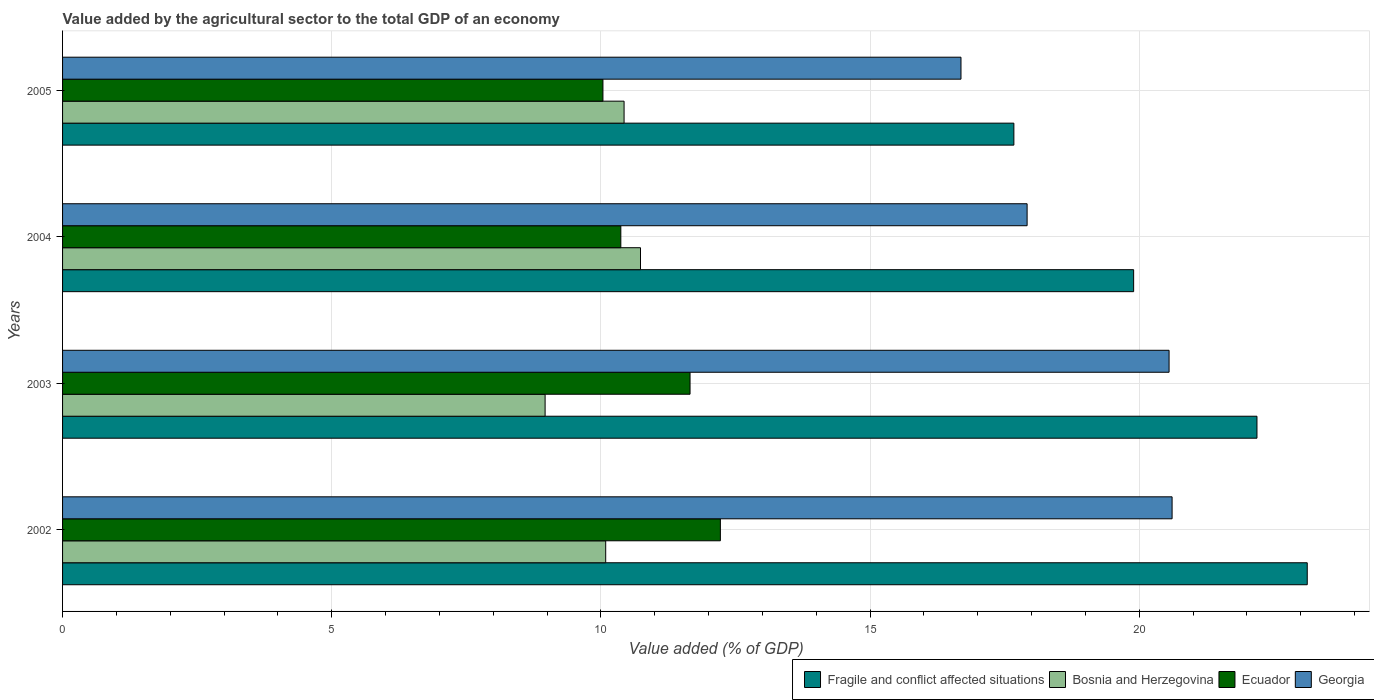Are the number of bars per tick equal to the number of legend labels?
Offer a terse response. Yes. Are the number of bars on each tick of the Y-axis equal?
Your response must be concise. Yes. How many bars are there on the 1st tick from the top?
Provide a succinct answer. 4. What is the value added by the agricultural sector to the total GDP in Bosnia and Herzegovina in 2003?
Make the answer very short. 8.96. Across all years, what is the maximum value added by the agricultural sector to the total GDP in Ecuador?
Give a very brief answer. 12.22. Across all years, what is the minimum value added by the agricultural sector to the total GDP in Fragile and conflict affected situations?
Keep it short and to the point. 17.67. In which year was the value added by the agricultural sector to the total GDP in Fragile and conflict affected situations minimum?
Ensure brevity in your answer.  2005. What is the total value added by the agricultural sector to the total GDP in Fragile and conflict affected situations in the graph?
Give a very brief answer. 82.88. What is the difference between the value added by the agricultural sector to the total GDP in Bosnia and Herzegovina in 2004 and that in 2005?
Your answer should be very brief. 0.31. What is the difference between the value added by the agricultural sector to the total GDP in Bosnia and Herzegovina in 2005 and the value added by the agricultural sector to the total GDP in Fragile and conflict affected situations in 2003?
Give a very brief answer. -11.76. What is the average value added by the agricultural sector to the total GDP in Ecuador per year?
Make the answer very short. 11.07. In the year 2005, what is the difference between the value added by the agricultural sector to the total GDP in Fragile and conflict affected situations and value added by the agricultural sector to the total GDP in Ecuador?
Your response must be concise. 7.63. In how many years, is the value added by the agricultural sector to the total GDP in Fragile and conflict affected situations greater than 5 %?
Provide a succinct answer. 4. What is the ratio of the value added by the agricultural sector to the total GDP in Fragile and conflict affected situations in 2002 to that in 2003?
Offer a terse response. 1.04. Is the difference between the value added by the agricultural sector to the total GDP in Fragile and conflict affected situations in 2002 and 2003 greater than the difference between the value added by the agricultural sector to the total GDP in Ecuador in 2002 and 2003?
Your answer should be compact. Yes. What is the difference between the highest and the second highest value added by the agricultural sector to the total GDP in Bosnia and Herzegovina?
Offer a very short reply. 0.31. What is the difference between the highest and the lowest value added by the agricultural sector to the total GDP in Georgia?
Your response must be concise. 3.92. In how many years, is the value added by the agricultural sector to the total GDP in Fragile and conflict affected situations greater than the average value added by the agricultural sector to the total GDP in Fragile and conflict affected situations taken over all years?
Provide a succinct answer. 2. What does the 1st bar from the top in 2002 represents?
Provide a short and direct response. Georgia. What does the 2nd bar from the bottom in 2002 represents?
Provide a short and direct response. Bosnia and Herzegovina. Is it the case that in every year, the sum of the value added by the agricultural sector to the total GDP in Bosnia and Herzegovina and value added by the agricultural sector to the total GDP in Fragile and conflict affected situations is greater than the value added by the agricultural sector to the total GDP in Ecuador?
Provide a succinct answer. Yes. How many years are there in the graph?
Your answer should be compact. 4. Are the values on the major ticks of X-axis written in scientific E-notation?
Provide a short and direct response. No. Does the graph contain any zero values?
Keep it short and to the point. No. What is the title of the graph?
Keep it short and to the point. Value added by the agricultural sector to the total GDP of an economy. What is the label or title of the X-axis?
Your response must be concise. Value added (% of GDP). What is the Value added (% of GDP) in Fragile and conflict affected situations in 2002?
Ensure brevity in your answer.  23.12. What is the Value added (% of GDP) in Bosnia and Herzegovina in 2002?
Make the answer very short. 10.09. What is the Value added (% of GDP) in Ecuador in 2002?
Offer a terse response. 12.22. What is the Value added (% of GDP) of Georgia in 2002?
Provide a short and direct response. 20.61. What is the Value added (% of GDP) of Fragile and conflict affected situations in 2003?
Your answer should be compact. 22.19. What is the Value added (% of GDP) in Bosnia and Herzegovina in 2003?
Make the answer very short. 8.96. What is the Value added (% of GDP) of Ecuador in 2003?
Offer a very short reply. 11.66. What is the Value added (% of GDP) in Georgia in 2003?
Offer a very short reply. 20.55. What is the Value added (% of GDP) of Fragile and conflict affected situations in 2004?
Your answer should be compact. 19.9. What is the Value added (% of GDP) of Bosnia and Herzegovina in 2004?
Keep it short and to the point. 10.74. What is the Value added (% of GDP) in Ecuador in 2004?
Offer a very short reply. 10.37. What is the Value added (% of GDP) of Georgia in 2004?
Give a very brief answer. 17.92. What is the Value added (% of GDP) of Fragile and conflict affected situations in 2005?
Your answer should be very brief. 17.67. What is the Value added (% of GDP) in Bosnia and Herzegovina in 2005?
Make the answer very short. 10.43. What is the Value added (% of GDP) of Ecuador in 2005?
Make the answer very short. 10.04. What is the Value added (% of GDP) of Georgia in 2005?
Offer a terse response. 16.69. Across all years, what is the maximum Value added (% of GDP) in Fragile and conflict affected situations?
Keep it short and to the point. 23.12. Across all years, what is the maximum Value added (% of GDP) in Bosnia and Herzegovina?
Ensure brevity in your answer.  10.74. Across all years, what is the maximum Value added (% of GDP) in Ecuador?
Ensure brevity in your answer.  12.22. Across all years, what is the maximum Value added (% of GDP) of Georgia?
Your answer should be very brief. 20.61. Across all years, what is the minimum Value added (% of GDP) in Fragile and conflict affected situations?
Your answer should be compact. 17.67. Across all years, what is the minimum Value added (% of GDP) in Bosnia and Herzegovina?
Give a very brief answer. 8.96. Across all years, what is the minimum Value added (% of GDP) in Ecuador?
Your answer should be compact. 10.04. Across all years, what is the minimum Value added (% of GDP) of Georgia?
Your response must be concise. 16.69. What is the total Value added (% of GDP) in Fragile and conflict affected situations in the graph?
Your response must be concise. 82.88. What is the total Value added (% of GDP) of Bosnia and Herzegovina in the graph?
Your answer should be very brief. 40.22. What is the total Value added (% of GDP) of Ecuador in the graph?
Your answer should be very brief. 44.28. What is the total Value added (% of GDP) in Georgia in the graph?
Your answer should be very brief. 75.77. What is the difference between the Value added (% of GDP) of Fragile and conflict affected situations in 2002 and that in 2003?
Offer a very short reply. 0.93. What is the difference between the Value added (% of GDP) of Bosnia and Herzegovina in 2002 and that in 2003?
Offer a terse response. 1.13. What is the difference between the Value added (% of GDP) in Ecuador in 2002 and that in 2003?
Your answer should be very brief. 0.56. What is the difference between the Value added (% of GDP) in Georgia in 2002 and that in 2003?
Ensure brevity in your answer.  0.06. What is the difference between the Value added (% of GDP) in Fragile and conflict affected situations in 2002 and that in 2004?
Your response must be concise. 3.23. What is the difference between the Value added (% of GDP) of Bosnia and Herzegovina in 2002 and that in 2004?
Make the answer very short. -0.65. What is the difference between the Value added (% of GDP) in Ecuador in 2002 and that in 2004?
Keep it short and to the point. 1.85. What is the difference between the Value added (% of GDP) of Georgia in 2002 and that in 2004?
Your answer should be compact. 2.69. What is the difference between the Value added (% of GDP) of Fragile and conflict affected situations in 2002 and that in 2005?
Give a very brief answer. 5.45. What is the difference between the Value added (% of GDP) in Bosnia and Herzegovina in 2002 and that in 2005?
Offer a very short reply. -0.34. What is the difference between the Value added (% of GDP) of Ecuador in 2002 and that in 2005?
Provide a short and direct response. 2.18. What is the difference between the Value added (% of GDP) of Georgia in 2002 and that in 2005?
Give a very brief answer. 3.92. What is the difference between the Value added (% of GDP) in Fragile and conflict affected situations in 2003 and that in 2004?
Provide a short and direct response. 2.29. What is the difference between the Value added (% of GDP) of Bosnia and Herzegovina in 2003 and that in 2004?
Your answer should be very brief. -1.77. What is the difference between the Value added (% of GDP) in Ecuador in 2003 and that in 2004?
Give a very brief answer. 1.29. What is the difference between the Value added (% of GDP) of Georgia in 2003 and that in 2004?
Your answer should be compact. 2.64. What is the difference between the Value added (% of GDP) in Fragile and conflict affected situations in 2003 and that in 2005?
Provide a short and direct response. 4.52. What is the difference between the Value added (% of GDP) in Bosnia and Herzegovina in 2003 and that in 2005?
Your answer should be compact. -1.47. What is the difference between the Value added (% of GDP) of Ecuador in 2003 and that in 2005?
Your response must be concise. 1.62. What is the difference between the Value added (% of GDP) of Georgia in 2003 and that in 2005?
Give a very brief answer. 3.87. What is the difference between the Value added (% of GDP) of Fragile and conflict affected situations in 2004 and that in 2005?
Your response must be concise. 2.22. What is the difference between the Value added (% of GDP) in Bosnia and Herzegovina in 2004 and that in 2005?
Provide a short and direct response. 0.31. What is the difference between the Value added (% of GDP) in Ecuador in 2004 and that in 2005?
Your answer should be very brief. 0.33. What is the difference between the Value added (% of GDP) of Georgia in 2004 and that in 2005?
Your answer should be compact. 1.23. What is the difference between the Value added (% of GDP) in Fragile and conflict affected situations in 2002 and the Value added (% of GDP) in Bosnia and Herzegovina in 2003?
Provide a succinct answer. 14.16. What is the difference between the Value added (% of GDP) in Fragile and conflict affected situations in 2002 and the Value added (% of GDP) in Ecuador in 2003?
Ensure brevity in your answer.  11.47. What is the difference between the Value added (% of GDP) of Fragile and conflict affected situations in 2002 and the Value added (% of GDP) of Georgia in 2003?
Your answer should be very brief. 2.57. What is the difference between the Value added (% of GDP) in Bosnia and Herzegovina in 2002 and the Value added (% of GDP) in Ecuador in 2003?
Your answer should be compact. -1.57. What is the difference between the Value added (% of GDP) in Bosnia and Herzegovina in 2002 and the Value added (% of GDP) in Georgia in 2003?
Your answer should be very brief. -10.47. What is the difference between the Value added (% of GDP) of Ecuador in 2002 and the Value added (% of GDP) of Georgia in 2003?
Provide a succinct answer. -8.34. What is the difference between the Value added (% of GDP) of Fragile and conflict affected situations in 2002 and the Value added (% of GDP) of Bosnia and Herzegovina in 2004?
Ensure brevity in your answer.  12.39. What is the difference between the Value added (% of GDP) in Fragile and conflict affected situations in 2002 and the Value added (% of GDP) in Ecuador in 2004?
Keep it short and to the point. 12.75. What is the difference between the Value added (% of GDP) in Fragile and conflict affected situations in 2002 and the Value added (% of GDP) in Georgia in 2004?
Offer a very short reply. 5.2. What is the difference between the Value added (% of GDP) of Bosnia and Herzegovina in 2002 and the Value added (% of GDP) of Ecuador in 2004?
Provide a short and direct response. -0.28. What is the difference between the Value added (% of GDP) of Bosnia and Herzegovina in 2002 and the Value added (% of GDP) of Georgia in 2004?
Keep it short and to the point. -7.83. What is the difference between the Value added (% of GDP) of Ecuador in 2002 and the Value added (% of GDP) of Georgia in 2004?
Provide a short and direct response. -5.7. What is the difference between the Value added (% of GDP) in Fragile and conflict affected situations in 2002 and the Value added (% of GDP) in Bosnia and Herzegovina in 2005?
Your response must be concise. 12.69. What is the difference between the Value added (% of GDP) in Fragile and conflict affected situations in 2002 and the Value added (% of GDP) in Ecuador in 2005?
Your answer should be very brief. 13.08. What is the difference between the Value added (% of GDP) of Fragile and conflict affected situations in 2002 and the Value added (% of GDP) of Georgia in 2005?
Provide a short and direct response. 6.43. What is the difference between the Value added (% of GDP) in Bosnia and Herzegovina in 2002 and the Value added (% of GDP) in Ecuador in 2005?
Provide a succinct answer. 0.05. What is the difference between the Value added (% of GDP) in Bosnia and Herzegovina in 2002 and the Value added (% of GDP) in Georgia in 2005?
Your answer should be compact. -6.6. What is the difference between the Value added (% of GDP) in Ecuador in 2002 and the Value added (% of GDP) in Georgia in 2005?
Make the answer very short. -4.47. What is the difference between the Value added (% of GDP) of Fragile and conflict affected situations in 2003 and the Value added (% of GDP) of Bosnia and Herzegovina in 2004?
Offer a very short reply. 11.45. What is the difference between the Value added (% of GDP) in Fragile and conflict affected situations in 2003 and the Value added (% of GDP) in Ecuador in 2004?
Ensure brevity in your answer.  11.82. What is the difference between the Value added (% of GDP) in Fragile and conflict affected situations in 2003 and the Value added (% of GDP) in Georgia in 2004?
Your response must be concise. 4.27. What is the difference between the Value added (% of GDP) of Bosnia and Herzegovina in 2003 and the Value added (% of GDP) of Ecuador in 2004?
Provide a succinct answer. -1.41. What is the difference between the Value added (% of GDP) of Bosnia and Herzegovina in 2003 and the Value added (% of GDP) of Georgia in 2004?
Offer a terse response. -8.95. What is the difference between the Value added (% of GDP) in Ecuador in 2003 and the Value added (% of GDP) in Georgia in 2004?
Give a very brief answer. -6.26. What is the difference between the Value added (% of GDP) of Fragile and conflict affected situations in 2003 and the Value added (% of GDP) of Bosnia and Herzegovina in 2005?
Your answer should be very brief. 11.76. What is the difference between the Value added (% of GDP) of Fragile and conflict affected situations in 2003 and the Value added (% of GDP) of Ecuador in 2005?
Give a very brief answer. 12.15. What is the difference between the Value added (% of GDP) of Fragile and conflict affected situations in 2003 and the Value added (% of GDP) of Georgia in 2005?
Offer a very short reply. 5.5. What is the difference between the Value added (% of GDP) in Bosnia and Herzegovina in 2003 and the Value added (% of GDP) in Ecuador in 2005?
Make the answer very short. -1.07. What is the difference between the Value added (% of GDP) in Bosnia and Herzegovina in 2003 and the Value added (% of GDP) in Georgia in 2005?
Give a very brief answer. -7.73. What is the difference between the Value added (% of GDP) of Ecuador in 2003 and the Value added (% of GDP) of Georgia in 2005?
Your answer should be compact. -5.03. What is the difference between the Value added (% of GDP) of Fragile and conflict affected situations in 2004 and the Value added (% of GDP) of Bosnia and Herzegovina in 2005?
Ensure brevity in your answer.  9.47. What is the difference between the Value added (% of GDP) in Fragile and conflict affected situations in 2004 and the Value added (% of GDP) in Ecuador in 2005?
Ensure brevity in your answer.  9.86. What is the difference between the Value added (% of GDP) in Fragile and conflict affected situations in 2004 and the Value added (% of GDP) in Georgia in 2005?
Your answer should be very brief. 3.21. What is the difference between the Value added (% of GDP) in Bosnia and Herzegovina in 2004 and the Value added (% of GDP) in Ecuador in 2005?
Give a very brief answer. 0.7. What is the difference between the Value added (% of GDP) of Bosnia and Herzegovina in 2004 and the Value added (% of GDP) of Georgia in 2005?
Provide a succinct answer. -5.95. What is the difference between the Value added (% of GDP) of Ecuador in 2004 and the Value added (% of GDP) of Georgia in 2005?
Ensure brevity in your answer.  -6.32. What is the average Value added (% of GDP) in Fragile and conflict affected situations per year?
Provide a succinct answer. 20.72. What is the average Value added (% of GDP) in Bosnia and Herzegovina per year?
Ensure brevity in your answer.  10.05. What is the average Value added (% of GDP) in Ecuador per year?
Give a very brief answer. 11.07. What is the average Value added (% of GDP) in Georgia per year?
Ensure brevity in your answer.  18.94. In the year 2002, what is the difference between the Value added (% of GDP) in Fragile and conflict affected situations and Value added (% of GDP) in Bosnia and Herzegovina?
Give a very brief answer. 13.03. In the year 2002, what is the difference between the Value added (% of GDP) of Fragile and conflict affected situations and Value added (% of GDP) of Ecuador?
Your answer should be compact. 10.9. In the year 2002, what is the difference between the Value added (% of GDP) in Fragile and conflict affected situations and Value added (% of GDP) in Georgia?
Keep it short and to the point. 2.51. In the year 2002, what is the difference between the Value added (% of GDP) in Bosnia and Herzegovina and Value added (% of GDP) in Ecuador?
Provide a short and direct response. -2.13. In the year 2002, what is the difference between the Value added (% of GDP) in Bosnia and Herzegovina and Value added (% of GDP) in Georgia?
Ensure brevity in your answer.  -10.52. In the year 2002, what is the difference between the Value added (% of GDP) in Ecuador and Value added (% of GDP) in Georgia?
Your response must be concise. -8.39. In the year 2003, what is the difference between the Value added (% of GDP) in Fragile and conflict affected situations and Value added (% of GDP) in Bosnia and Herzegovina?
Provide a succinct answer. 13.22. In the year 2003, what is the difference between the Value added (% of GDP) in Fragile and conflict affected situations and Value added (% of GDP) in Ecuador?
Make the answer very short. 10.53. In the year 2003, what is the difference between the Value added (% of GDP) in Fragile and conflict affected situations and Value added (% of GDP) in Georgia?
Keep it short and to the point. 1.63. In the year 2003, what is the difference between the Value added (% of GDP) of Bosnia and Herzegovina and Value added (% of GDP) of Ecuador?
Ensure brevity in your answer.  -2.69. In the year 2003, what is the difference between the Value added (% of GDP) in Bosnia and Herzegovina and Value added (% of GDP) in Georgia?
Provide a short and direct response. -11.59. In the year 2003, what is the difference between the Value added (% of GDP) of Ecuador and Value added (% of GDP) of Georgia?
Give a very brief answer. -8.9. In the year 2004, what is the difference between the Value added (% of GDP) of Fragile and conflict affected situations and Value added (% of GDP) of Bosnia and Herzegovina?
Give a very brief answer. 9.16. In the year 2004, what is the difference between the Value added (% of GDP) of Fragile and conflict affected situations and Value added (% of GDP) of Ecuador?
Your answer should be compact. 9.53. In the year 2004, what is the difference between the Value added (% of GDP) of Fragile and conflict affected situations and Value added (% of GDP) of Georgia?
Offer a very short reply. 1.98. In the year 2004, what is the difference between the Value added (% of GDP) in Bosnia and Herzegovina and Value added (% of GDP) in Ecuador?
Ensure brevity in your answer.  0.37. In the year 2004, what is the difference between the Value added (% of GDP) of Bosnia and Herzegovina and Value added (% of GDP) of Georgia?
Your response must be concise. -7.18. In the year 2004, what is the difference between the Value added (% of GDP) in Ecuador and Value added (% of GDP) in Georgia?
Provide a short and direct response. -7.55. In the year 2005, what is the difference between the Value added (% of GDP) in Fragile and conflict affected situations and Value added (% of GDP) in Bosnia and Herzegovina?
Your response must be concise. 7.24. In the year 2005, what is the difference between the Value added (% of GDP) in Fragile and conflict affected situations and Value added (% of GDP) in Ecuador?
Ensure brevity in your answer.  7.63. In the year 2005, what is the difference between the Value added (% of GDP) in Fragile and conflict affected situations and Value added (% of GDP) in Georgia?
Offer a terse response. 0.98. In the year 2005, what is the difference between the Value added (% of GDP) of Bosnia and Herzegovina and Value added (% of GDP) of Ecuador?
Your response must be concise. 0.39. In the year 2005, what is the difference between the Value added (% of GDP) of Bosnia and Herzegovina and Value added (% of GDP) of Georgia?
Provide a short and direct response. -6.26. In the year 2005, what is the difference between the Value added (% of GDP) in Ecuador and Value added (% of GDP) in Georgia?
Your answer should be compact. -6.65. What is the ratio of the Value added (% of GDP) in Fragile and conflict affected situations in 2002 to that in 2003?
Offer a very short reply. 1.04. What is the ratio of the Value added (% of GDP) of Bosnia and Herzegovina in 2002 to that in 2003?
Ensure brevity in your answer.  1.13. What is the ratio of the Value added (% of GDP) in Ecuador in 2002 to that in 2003?
Your answer should be very brief. 1.05. What is the ratio of the Value added (% of GDP) in Fragile and conflict affected situations in 2002 to that in 2004?
Your response must be concise. 1.16. What is the ratio of the Value added (% of GDP) of Bosnia and Herzegovina in 2002 to that in 2004?
Offer a very short reply. 0.94. What is the ratio of the Value added (% of GDP) of Ecuador in 2002 to that in 2004?
Offer a terse response. 1.18. What is the ratio of the Value added (% of GDP) in Georgia in 2002 to that in 2004?
Provide a succinct answer. 1.15. What is the ratio of the Value added (% of GDP) of Fragile and conflict affected situations in 2002 to that in 2005?
Ensure brevity in your answer.  1.31. What is the ratio of the Value added (% of GDP) in Bosnia and Herzegovina in 2002 to that in 2005?
Offer a terse response. 0.97. What is the ratio of the Value added (% of GDP) in Ecuador in 2002 to that in 2005?
Your response must be concise. 1.22. What is the ratio of the Value added (% of GDP) in Georgia in 2002 to that in 2005?
Offer a very short reply. 1.24. What is the ratio of the Value added (% of GDP) of Fragile and conflict affected situations in 2003 to that in 2004?
Keep it short and to the point. 1.12. What is the ratio of the Value added (% of GDP) in Bosnia and Herzegovina in 2003 to that in 2004?
Ensure brevity in your answer.  0.83. What is the ratio of the Value added (% of GDP) of Ecuador in 2003 to that in 2004?
Your answer should be compact. 1.12. What is the ratio of the Value added (% of GDP) of Georgia in 2003 to that in 2004?
Ensure brevity in your answer.  1.15. What is the ratio of the Value added (% of GDP) of Fragile and conflict affected situations in 2003 to that in 2005?
Provide a short and direct response. 1.26. What is the ratio of the Value added (% of GDP) of Bosnia and Herzegovina in 2003 to that in 2005?
Provide a short and direct response. 0.86. What is the ratio of the Value added (% of GDP) of Ecuador in 2003 to that in 2005?
Offer a very short reply. 1.16. What is the ratio of the Value added (% of GDP) in Georgia in 2003 to that in 2005?
Ensure brevity in your answer.  1.23. What is the ratio of the Value added (% of GDP) in Fragile and conflict affected situations in 2004 to that in 2005?
Offer a terse response. 1.13. What is the ratio of the Value added (% of GDP) of Bosnia and Herzegovina in 2004 to that in 2005?
Your answer should be compact. 1.03. What is the ratio of the Value added (% of GDP) of Ecuador in 2004 to that in 2005?
Offer a terse response. 1.03. What is the ratio of the Value added (% of GDP) in Georgia in 2004 to that in 2005?
Ensure brevity in your answer.  1.07. What is the difference between the highest and the second highest Value added (% of GDP) in Fragile and conflict affected situations?
Ensure brevity in your answer.  0.93. What is the difference between the highest and the second highest Value added (% of GDP) of Bosnia and Herzegovina?
Your answer should be very brief. 0.31. What is the difference between the highest and the second highest Value added (% of GDP) of Ecuador?
Provide a succinct answer. 0.56. What is the difference between the highest and the second highest Value added (% of GDP) in Georgia?
Offer a very short reply. 0.06. What is the difference between the highest and the lowest Value added (% of GDP) in Fragile and conflict affected situations?
Provide a short and direct response. 5.45. What is the difference between the highest and the lowest Value added (% of GDP) in Bosnia and Herzegovina?
Offer a very short reply. 1.77. What is the difference between the highest and the lowest Value added (% of GDP) of Ecuador?
Offer a terse response. 2.18. What is the difference between the highest and the lowest Value added (% of GDP) in Georgia?
Make the answer very short. 3.92. 